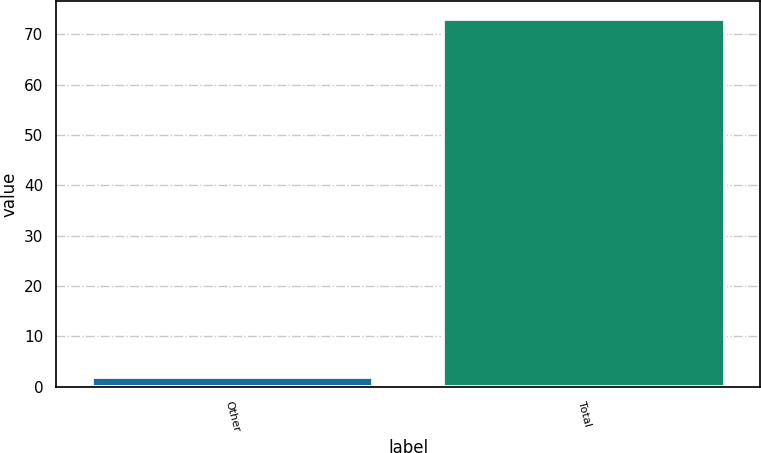<chart> <loc_0><loc_0><loc_500><loc_500><bar_chart><fcel>Other<fcel>Total<nl><fcel>2<fcel>73<nl></chart> 